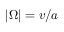Convert formula to latex. <formula><loc_0><loc_0><loc_500><loc_500>| { \boldsymbol \Omega } | = v / a</formula> 